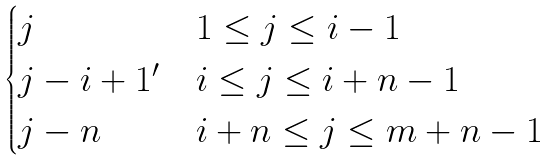<formula> <loc_0><loc_0><loc_500><loc_500>\begin{cases} j & 1 \leq j \leq i - 1 \\ j - i + 1 ^ { \prime } & i \leq j \leq i + n - 1 \\ j - n & i + n \leq j \leq m + n - 1 \end{cases}</formula> 